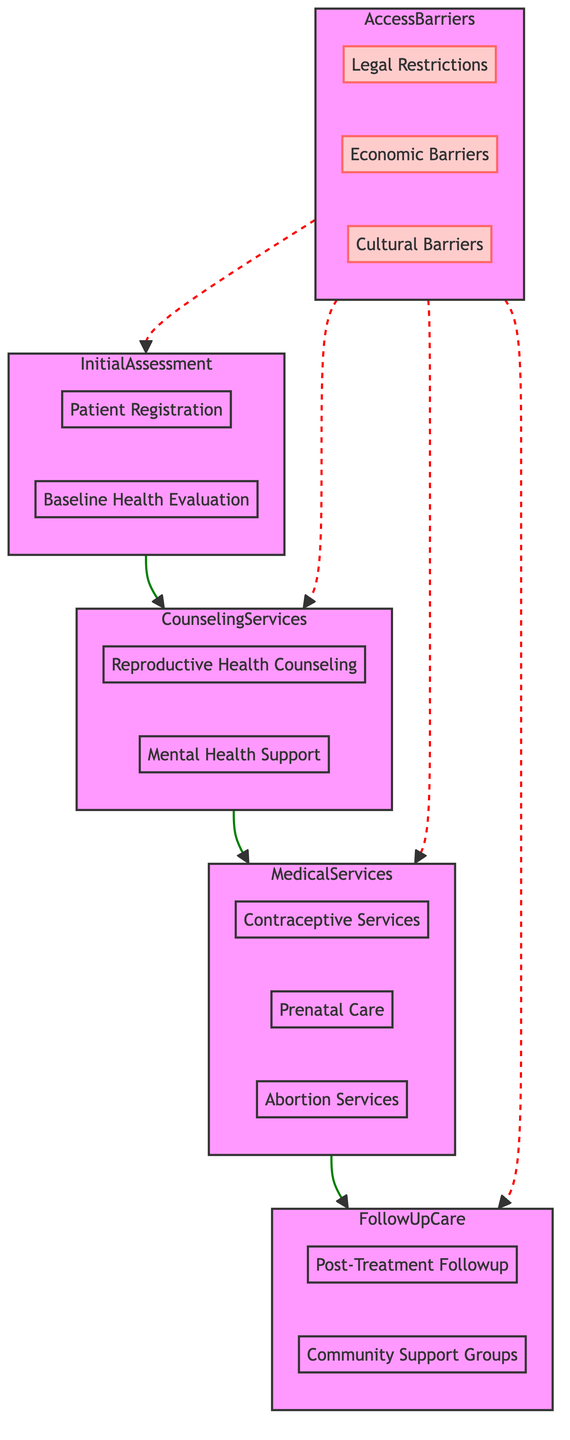What are the components of the Initial Assessment? The Initial Assessment includes two components: Patient Registration and Baseline Health Evaluation. These can be found under the Initial Assessment subgraph of the diagram.
Answer: Patient Registration, Baseline Health Evaluation How many steps are there in the Medical Services section? The Medical Services section contains three steps: Contraceptive Services, Prenatal Care, and Abortion Services. This can be identified by counting the components in the Medical Services subgraph.
Answer: Three What comes after Counseling Services? After Counseling Services, the next step is Medical Services. This information is derived from the flow direction between the Counseling Services and Medical Services nodes in the diagram.
Answer: Medical Services Which barriers are identified in the Access Barriers section? The Access Barriers section identifies three barriers: Legal Restrictions, Economic Barriers, and Cultural Barriers, as indicated in the Access Barriers subgraph.
Answer: Legal Restrictions, Economic Barriers, Cultural Barriers What type of care is included in Follow-Up Care? Follow-Up Care includes two types of care: Post-Treatment Followup and Community Support Groups, which are specified in the Follow-Up Care subgraph of the diagram.
Answer: Post-Treatment Followup, Community Support Groups What is the relationship between Access Barriers and Clinical Pathway components? Access Barriers are connected to all Clinical Pathway components through a dashed line, indicating indirect impacts on the Initial Assessment, Counseling Services, Medical Services, and Follow-Up Care. This is shown in the flow diagram with the dashed lines leading from Access Barriers to the components.
Answer: Indirect impact How many components are in the Counseling Services section? The Counseling Services section has two components: Reproductive Health Counseling and Mental Health Support. These can be observed in the Counseling Services subgraph of the diagram.
Answer: Two What is the purpose of the Medical Services section? The Medical Services section provides access to essential reproductive health options, such as contraceptive services, prenatal care, and abortion services, as specified in its description.
Answer: Access to reproductive health options What type of barriers are represented by the dashed lines? The dashed lines represent Access Barriers, which include Legal, Economic, and Cultural Barriers. These barriers indirectly influence the Clinical Pathway components by showing various obstacles to access.
Answer: Access Barriers 